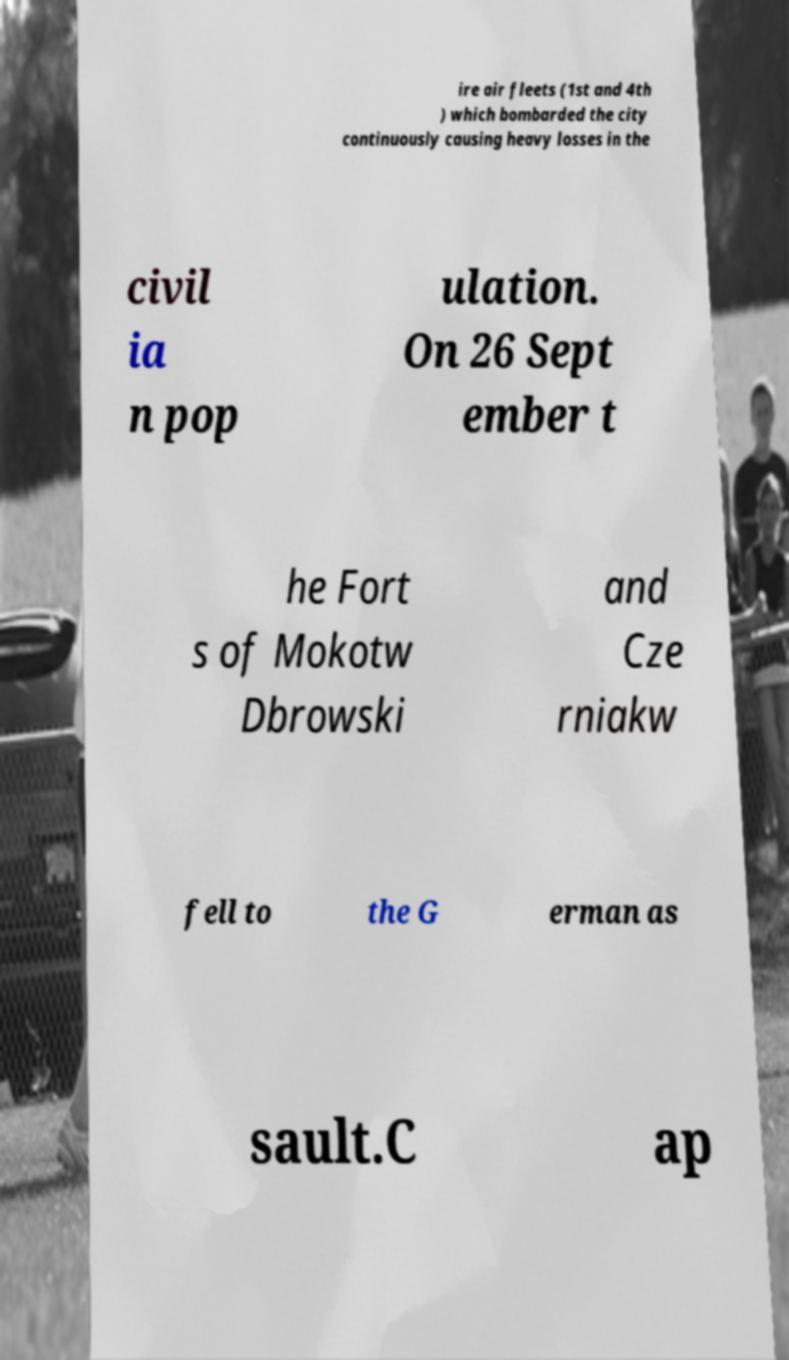There's text embedded in this image that I need extracted. Can you transcribe it verbatim? ire air fleets (1st and 4th ) which bombarded the city continuously causing heavy losses in the civil ia n pop ulation. On 26 Sept ember t he Fort s of Mokotw Dbrowski and Cze rniakw fell to the G erman as sault.C ap 